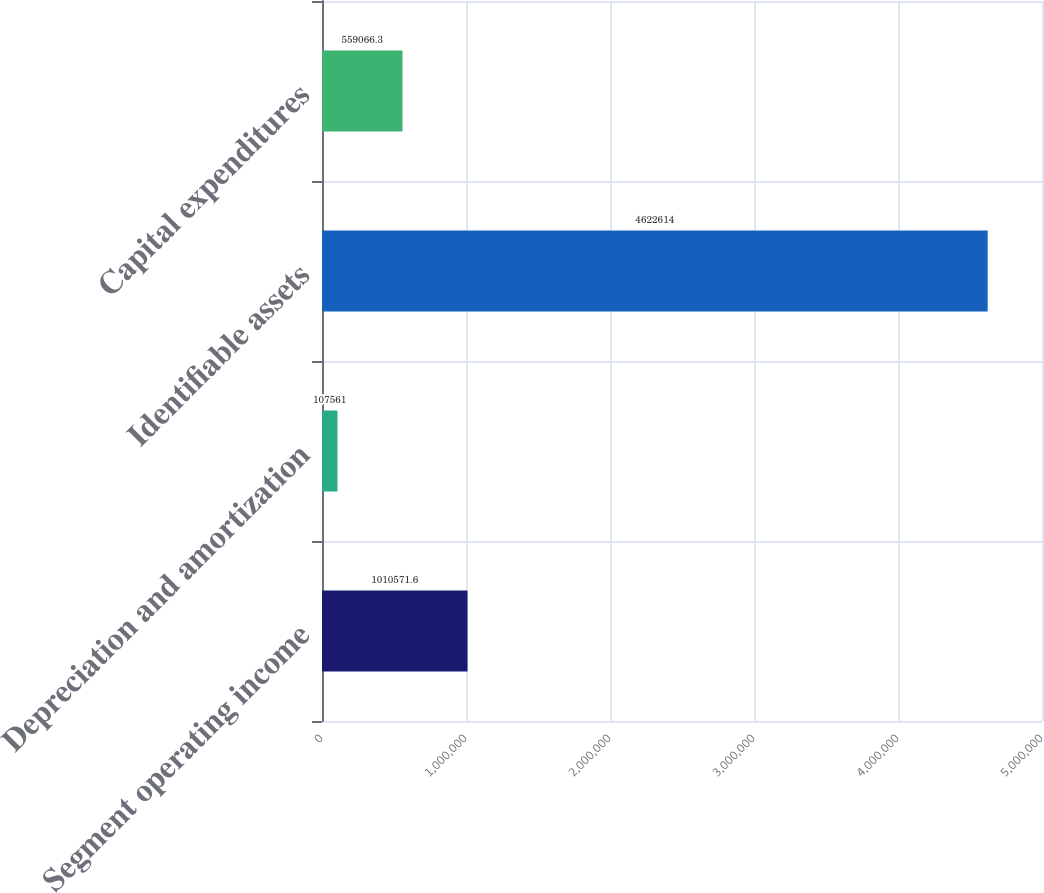Convert chart to OTSL. <chart><loc_0><loc_0><loc_500><loc_500><bar_chart><fcel>Segment operating income<fcel>Depreciation and amortization<fcel>Identifiable assets<fcel>Capital expenditures<nl><fcel>1.01057e+06<fcel>107561<fcel>4.62261e+06<fcel>559066<nl></chart> 